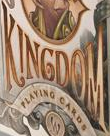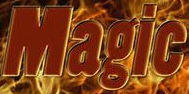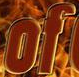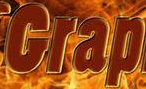Transcribe the words shown in these images in order, separated by a semicolon. KINGDOM; Magic; of; Grap 